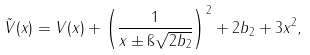Convert formula to latex. <formula><loc_0><loc_0><loc_500><loc_500>\tilde { V } ( x ) = V ( x ) + \left ( \frac { 1 } { x \pm \i \sqrt { 2 b _ { 2 } } } \right ) ^ { 2 } + 2 b _ { 2 } + 3 x ^ { 2 } ,</formula> 